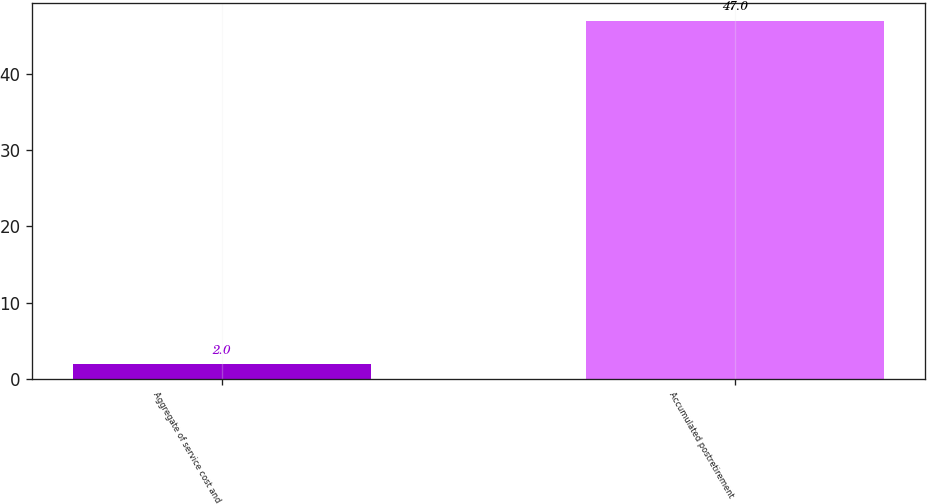Convert chart to OTSL. <chart><loc_0><loc_0><loc_500><loc_500><bar_chart><fcel>Aggregate of service cost and<fcel>Accumulated postretirement<nl><fcel>2<fcel>47<nl></chart> 